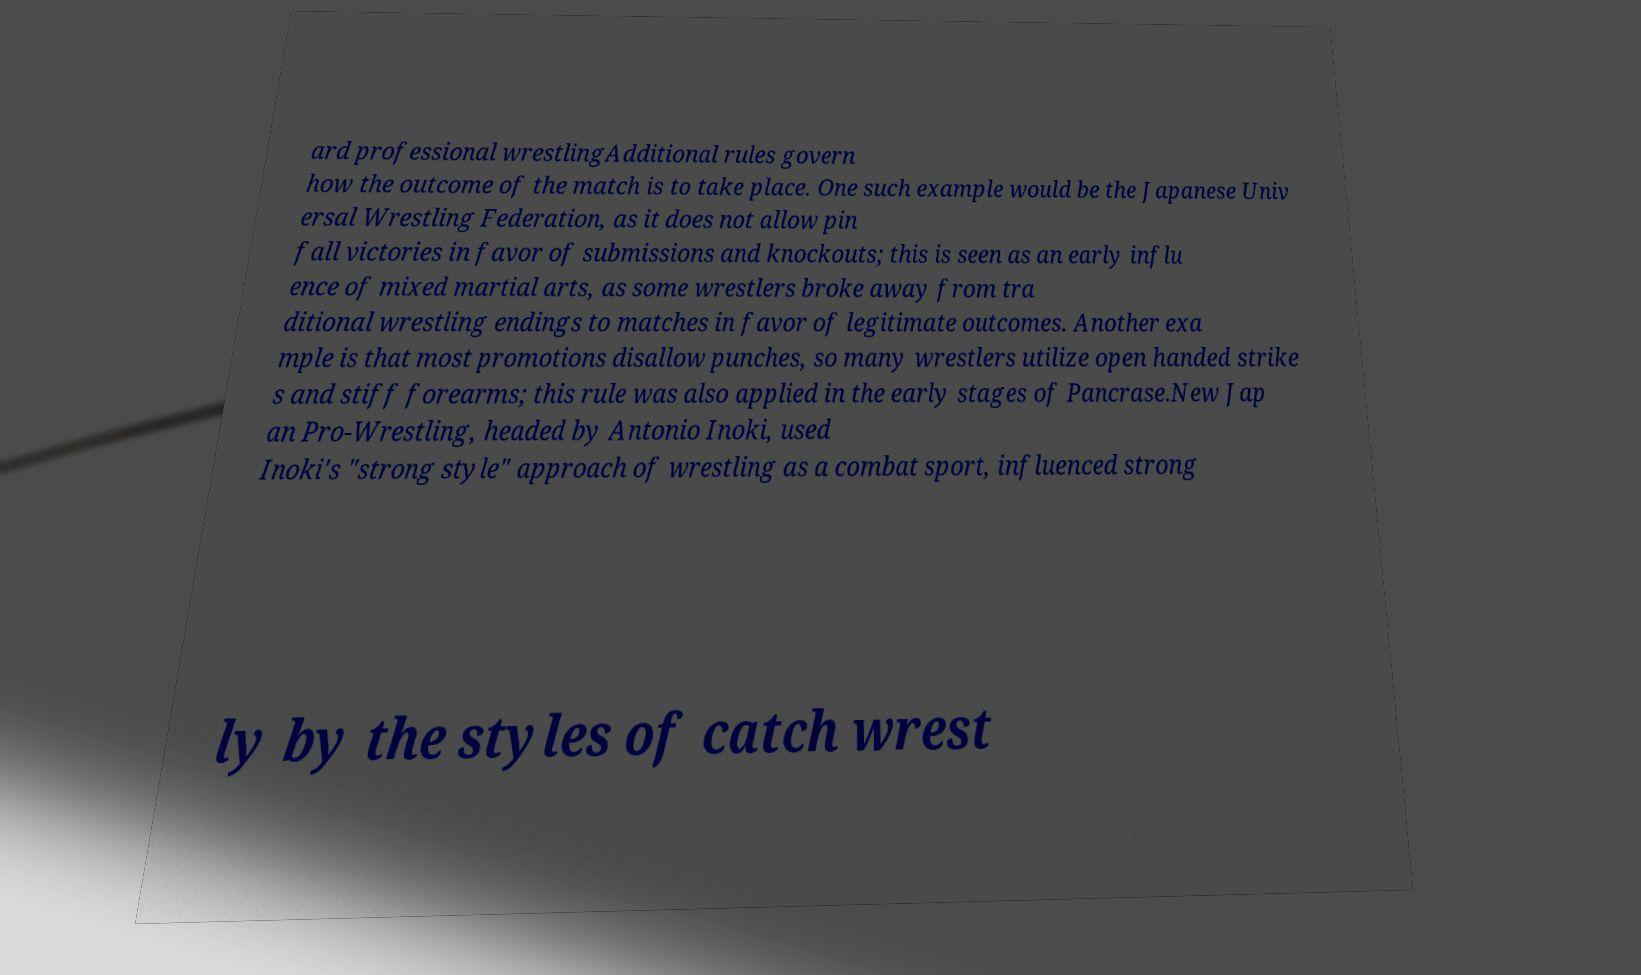What messages or text are displayed in this image? I need them in a readable, typed format. ard professional wrestlingAdditional rules govern how the outcome of the match is to take place. One such example would be the Japanese Univ ersal Wrestling Federation, as it does not allow pin fall victories in favor of submissions and knockouts; this is seen as an early influ ence of mixed martial arts, as some wrestlers broke away from tra ditional wrestling endings to matches in favor of legitimate outcomes. Another exa mple is that most promotions disallow punches, so many wrestlers utilize open handed strike s and stiff forearms; this rule was also applied in the early stages of Pancrase.New Jap an Pro-Wrestling, headed by Antonio Inoki, used Inoki's "strong style" approach of wrestling as a combat sport, influenced strong ly by the styles of catch wrest 